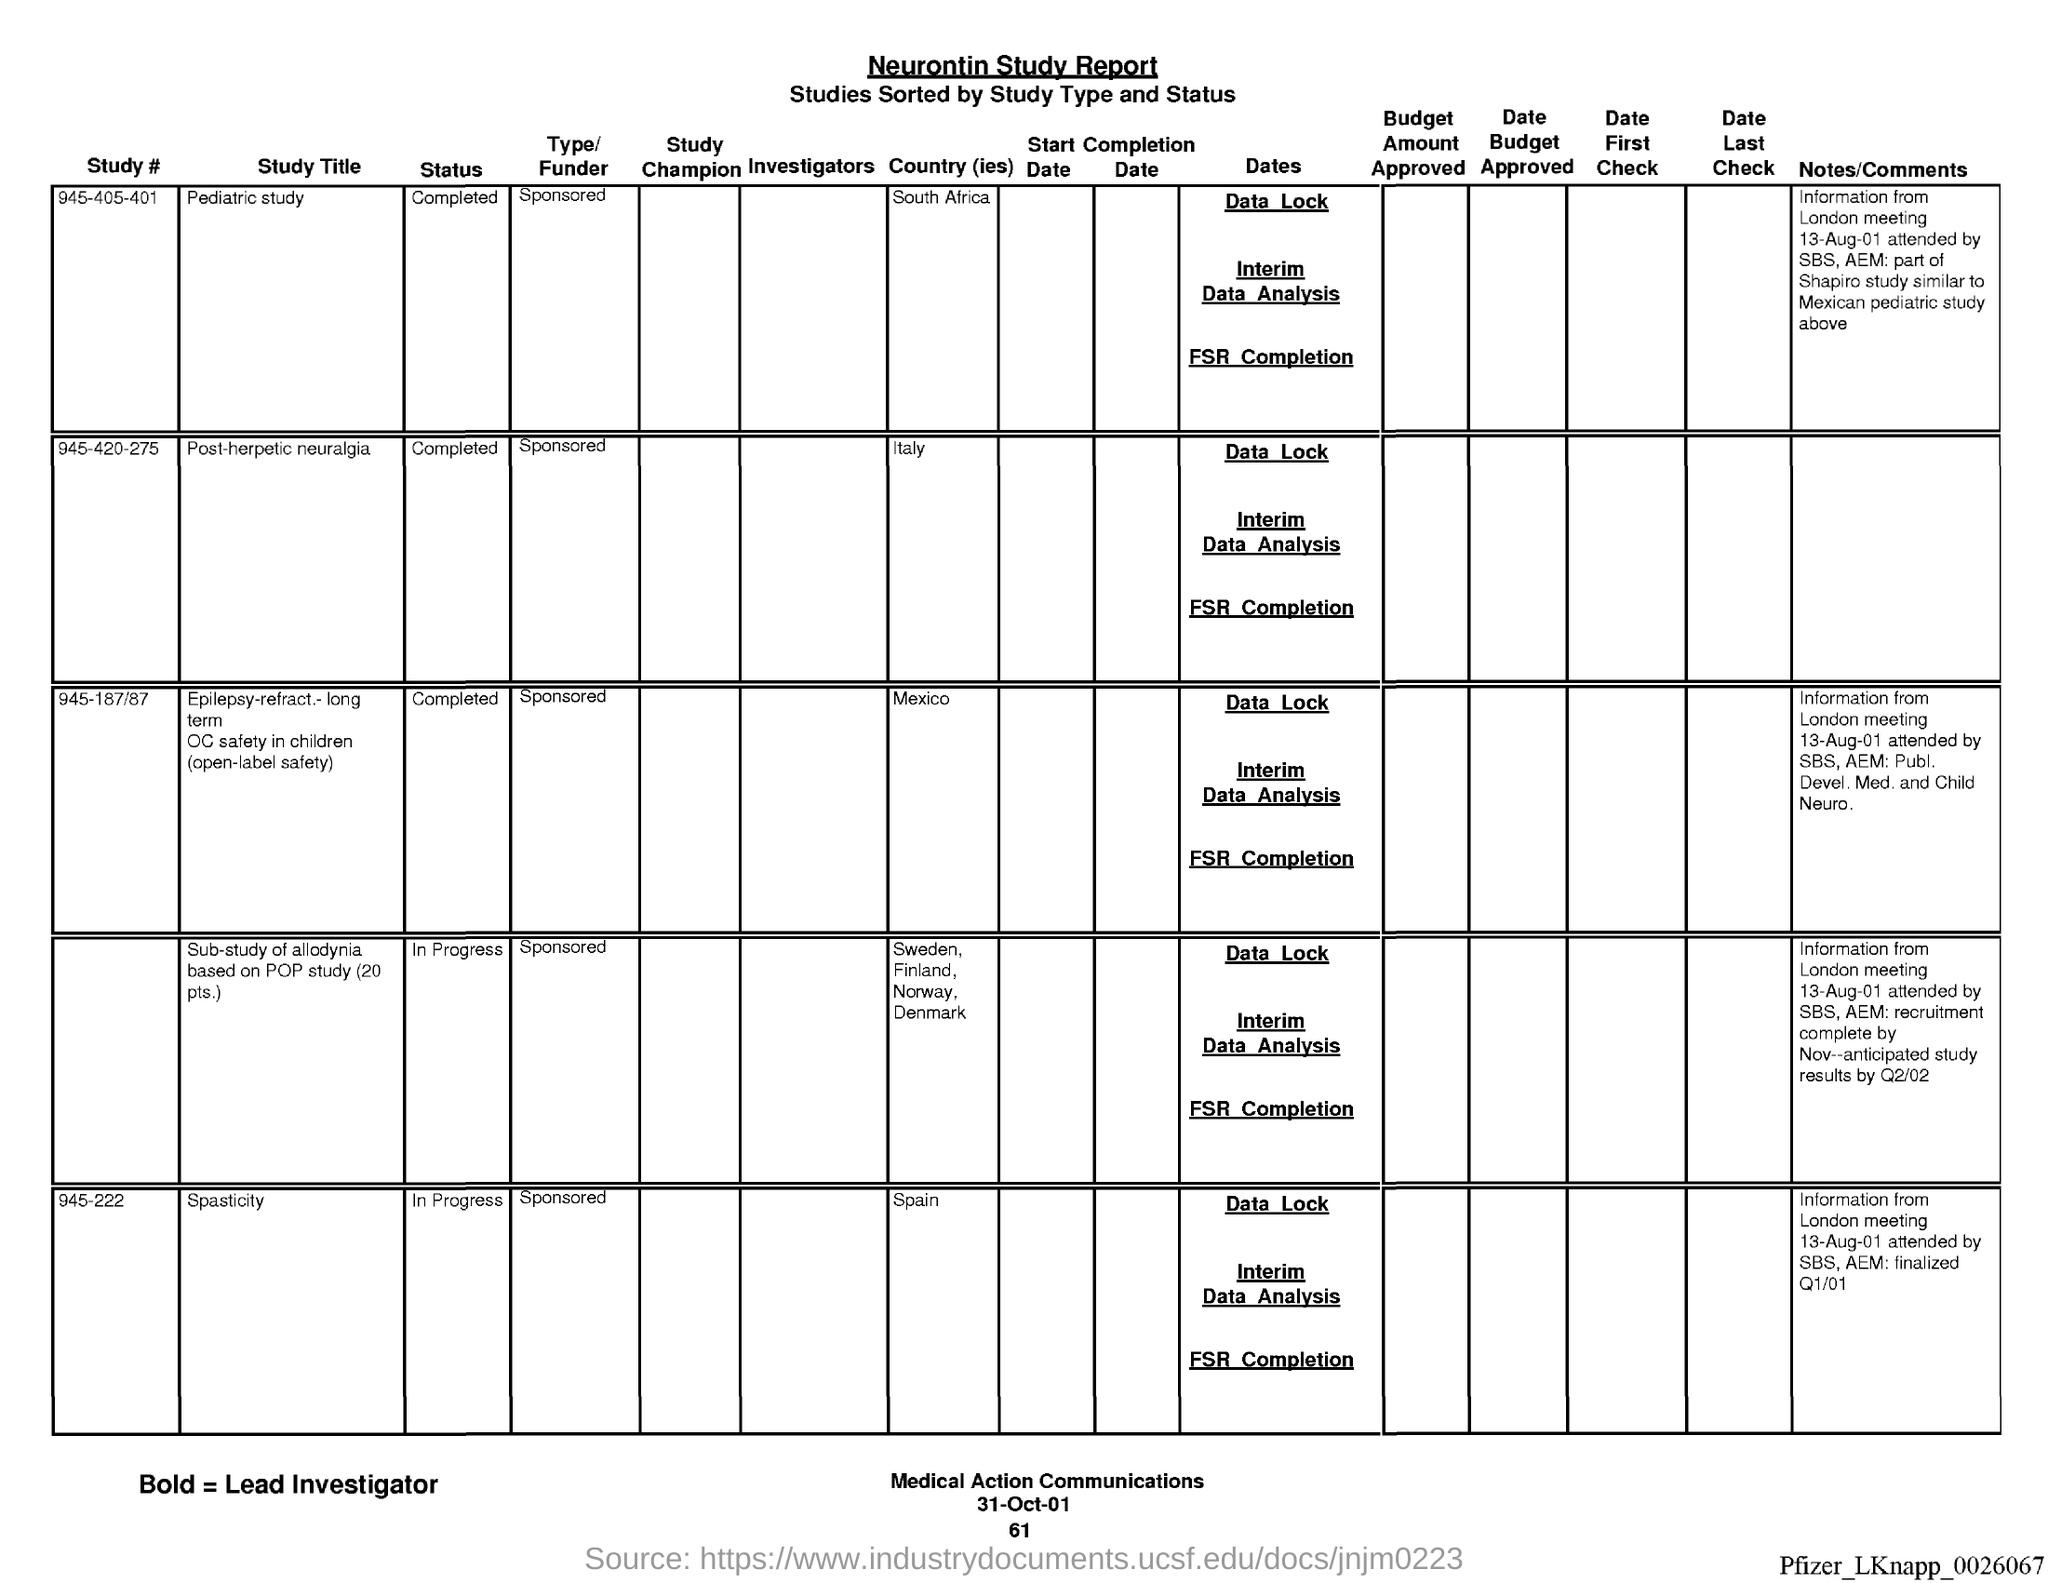What is the name of the report ?
Your response must be concise. Neurontin Study report. What is the date at bottom of the page?
Ensure brevity in your answer.  31-Oct-01. What is the page number below date?
Your answer should be compact. 61. 